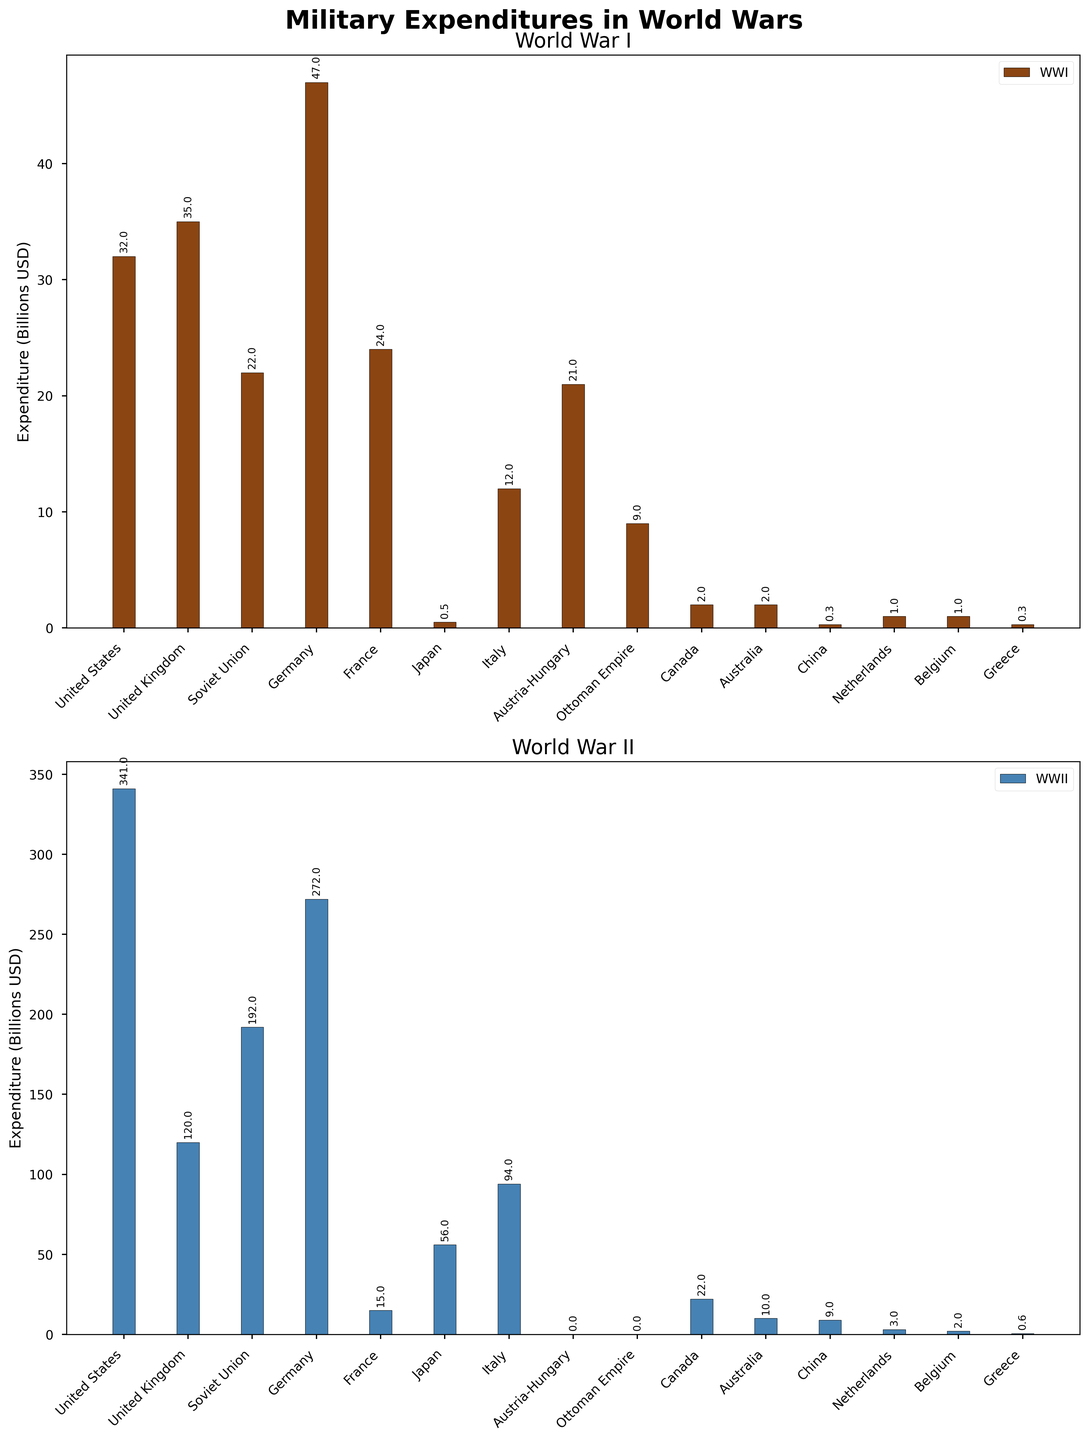Which country had the highest military expenditure in World War I? By observing the height of the bars in the WWI plot, it can be seen that Germany had the highest bar, indicating the highest expenditure.
Answer: Germany Which war saw a greater overall expenditure from the United States, WWI or WWII? By comparing the heights of the bars for the United States in both plots, it is clear that the bar for WWII is significantly higher.
Answer: WWII What was the total military expenditure of Canada in both World Wars combined? First, locate the bars for Canada on both plots. Their expenditures are 2 billion USD in WWI and 22 billion USD in WWII. Adding these together gives 24 billion USD.
Answer: 24 billion USD Compare the military expenditures of France in both World Wars. Which one was higher? Viewing the bars for France in both plots, it is clear that the bar for WWI is higher than the bar for WWII.
Answer: WWI Which two countries had zero military expenditure in World War II? The bars for Austria-Hungary and the Ottoman Empire in the WWII plot are both at zero height, indicating no expenditure.
Answer: Austria-Hungary and Ottoman Empire Calculate the difference in military expenditure between Germany and Japan in WWII. The bars show Germany has an expenditure of 272 billion USD and Japan 56 billion USD in WWII. Subtracting these, 272-56 = 216 billion USD.
Answer: 216 billion USD What visual cue indicates which war is being represented in each subplot? The first subplot uses a brown color for WWI bars and the second subplot uses a blue color for WWII bars. The titles "World War I" and "World War II" also indicate this.
Answer: Color and titles Which country increased its military expenditure the most from WWI to WWII? By observing the two sets of bars, Japan had the smallest bar in WWI and a much larger bar in WWII, indicating a significant increase.
Answer: Japan Was Italy's military expenditure higher in WWI or WWII? By comparing the height of Italy's bars, it is shown that the bar for WWII is much higher than the one for WWI.
Answer: WWII What is the combined military expenditure of the United Kingdom and the Soviet Union in WWII? The bars show the United Kingdom at 120 billion USD and the Soviet Union at 192 billion USD in WWII. Adding these together gives 312 billion USD.
Answer: 312 billion USD 